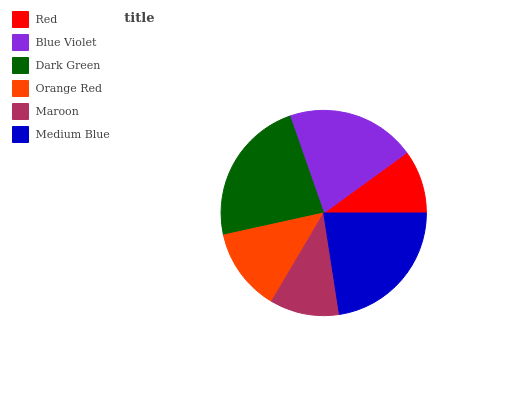Is Red the minimum?
Answer yes or no. Yes. Is Dark Green the maximum?
Answer yes or no. Yes. Is Blue Violet the minimum?
Answer yes or no. No. Is Blue Violet the maximum?
Answer yes or no. No. Is Blue Violet greater than Red?
Answer yes or no. Yes. Is Red less than Blue Violet?
Answer yes or no. Yes. Is Red greater than Blue Violet?
Answer yes or no. No. Is Blue Violet less than Red?
Answer yes or no. No. Is Blue Violet the high median?
Answer yes or no. Yes. Is Orange Red the low median?
Answer yes or no. Yes. Is Orange Red the high median?
Answer yes or no. No. Is Dark Green the low median?
Answer yes or no. No. 